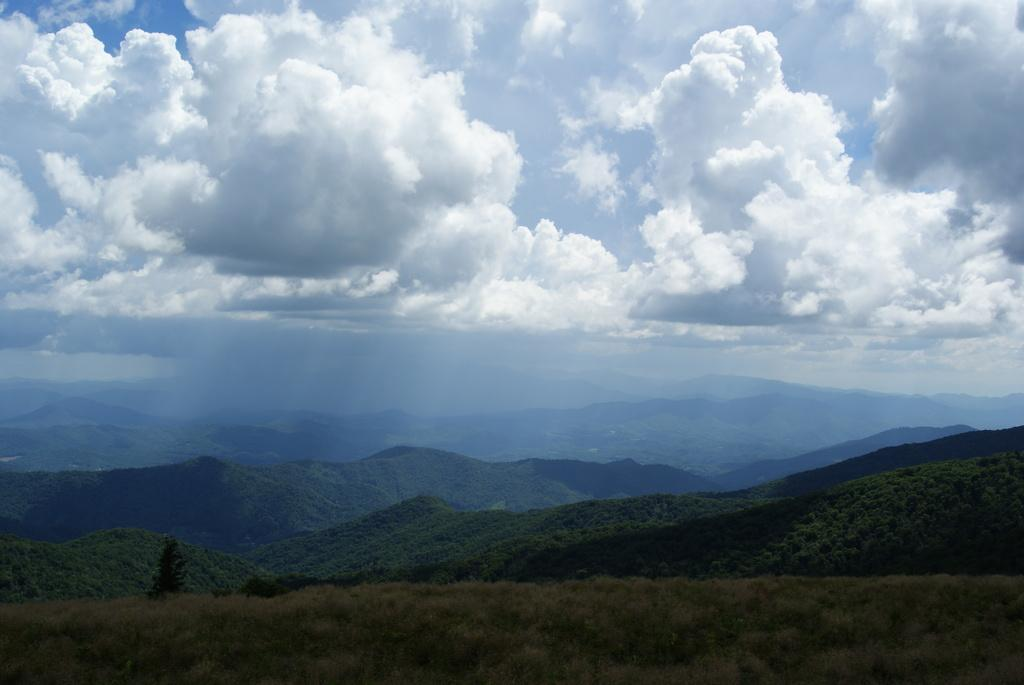What type of vegetation can be seen in the image? There are trees in the image. What type of geographical feature is present in the image? There are hills in the image. What can be seen in the sky in the image? There are clouds in the image. What color is the scarf worn by the team in the image? There is no team or scarf present in the image. What time of day is depicted in the image? The time of day cannot be determined from the image, as there is no specific indication of day or night. 